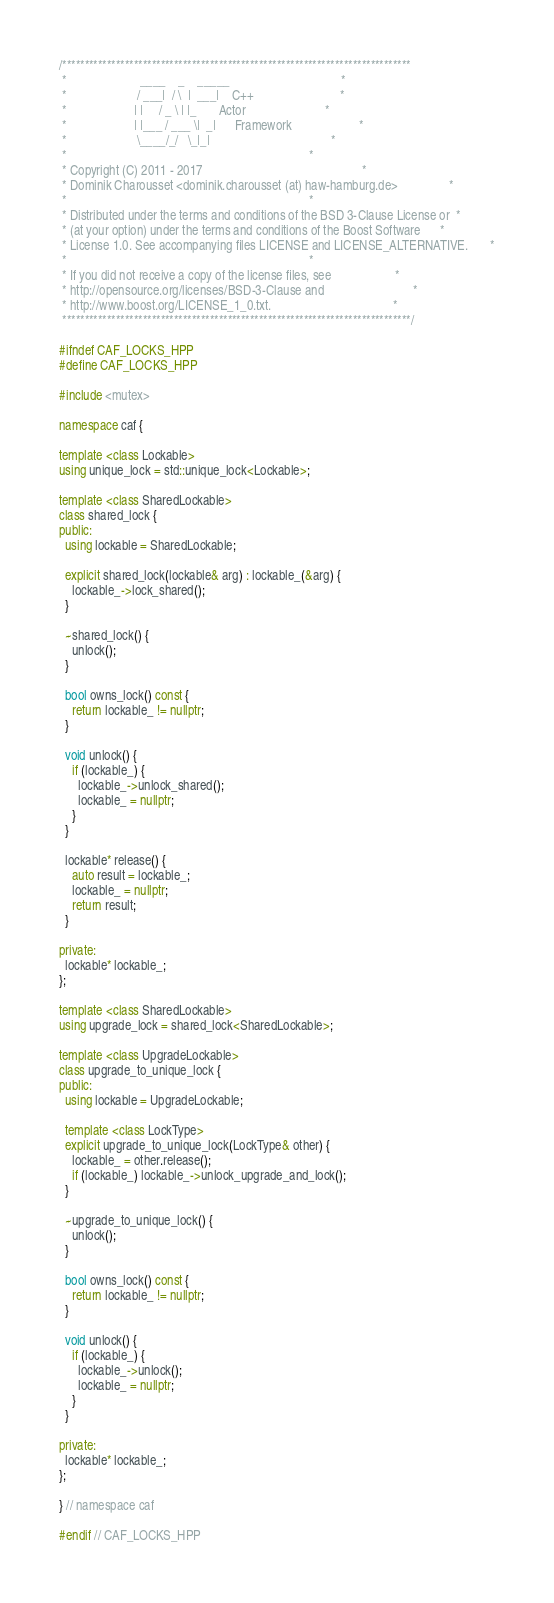Convert code to text. <code><loc_0><loc_0><loc_500><loc_500><_C++_>/******************************************************************************
 *                       ____    _    _____                                   *
 *                      / ___|  / \  |  ___|    C++                           *
 *                     | |     / _ \ | |_       Actor                         *
 *                     | |___ / ___ \|  _|      Framework                     *
 *                      \____/_/   \_|_|                                      *
 *                                                                            *
 * Copyright (C) 2011 - 2017                                                  *
 * Dominik Charousset <dominik.charousset (at) haw-hamburg.de>                *
 *                                                                            *
 * Distributed under the terms and conditions of the BSD 3-Clause License or  *
 * (at your option) under the terms and conditions of the Boost Software      *
 * License 1.0. See accompanying files LICENSE and LICENSE_ALTERNATIVE.       *
 *                                                                            *
 * If you did not receive a copy of the license files, see                    *
 * http://opensource.org/licenses/BSD-3-Clause and                            *
 * http://www.boost.org/LICENSE_1_0.txt.                                      *
 ******************************************************************************/

#ifndef CAF_LOCKS_HPP
#define CAF_LOCKS_HPP

#include <mutex>

namespace caf {

template <class Lockable>
using unique_lock = std::unique_lock<Lockable>;

template <class SharedLockable>
class shared_lock {
public:
  using lockable = SharedLockable;

  explicit shared_lock(lockable& arg) : lockable_(&arg) {
    lockable_->lock_shared();
  }

  ~shared_lock() {
    unlock();
  }

  bool owns_lock() const {
    return lockable_ != nullptr;
  }

  void unlock() {
    if (lockable_) {
      lockable_->unlock_shared();
      lockable_ = nullptr;
    }
  }

  lockable* release() {
    auto result = lockable_;
    lockable_ = nullptr;
    return result;
  }

private:
  lockable* lockable_;
};

template <class SharedLockable>
using upgrade_lock = shared_lock<SharedLockable>;

template <class UpgradeLockable>
class upgrade_to_unique_lock {
public:
  using lockable = UpgradeLockable;

  template <class LockType>
  explicit upgrade_to_unique_lock(LockType& other) {
    lockable_ = other.release();
    if (lockable_) lockable_->unlock_upgrade_and_lock();
  }

  ~upgrade_to_unique_lock() {
    unlock();
  }

  bool owns_lock() const {
    return lockable_ != nullptr;
  }

  void unlock() {
    if (lockable_) {
      lockable_->unlock();
      lockable_ = nullptr;
    }
  }

private:
  lockable* lockable_;
};

} // namespace caf

#endif // CAF_LOCKS_HPP
</code> 